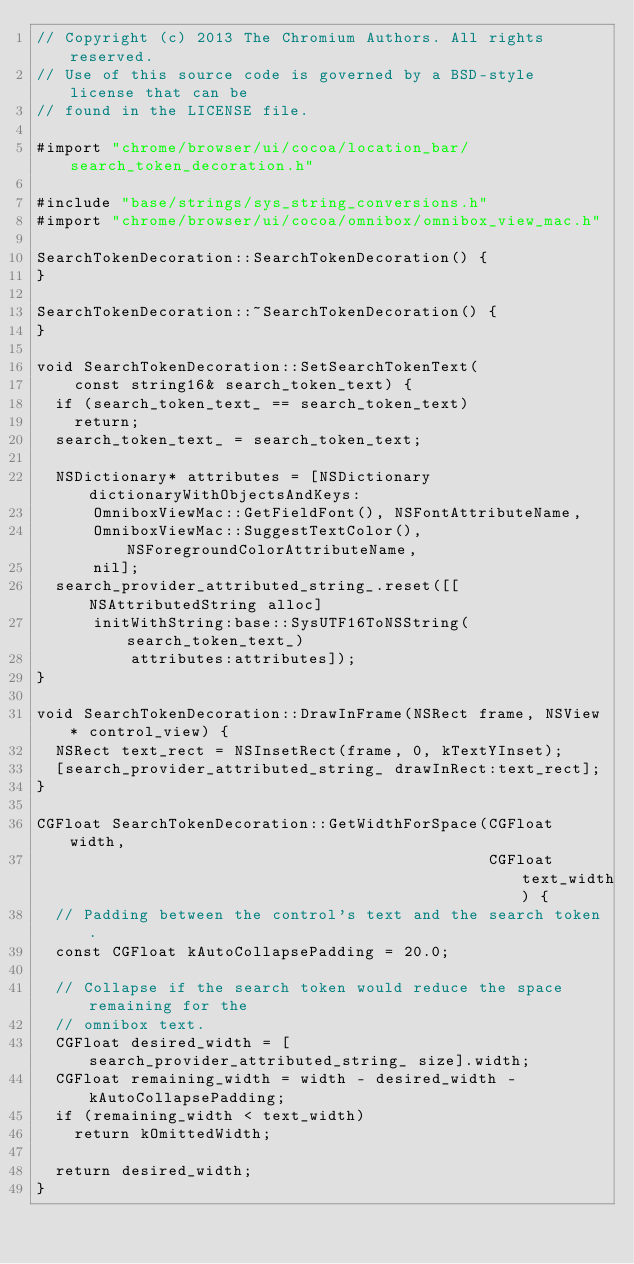<code> <loc_0><loc_0><loc_500><loc_500><_ObjectiveC_>// Copyright (c) 2013 The Chromium Authors. All rights reserved.
// Use of this source code is governed by a BSD-style license that can be
// found in the LICENSE file.

#import "chrome/browser/ui/cocoa/location_bar/search_token_decoration.h"

#include "base/strings/sys_string_conversions.h"
#import "chrome/browser/ui/cocoa/omnibox/omnibox_view_mac.h"

SearchTokenDecoration::SearchTokenDecoration() {
}

SearchTokenDecoration::~SearchTokenDecoration() {
}

void SearchTokenDecoration::SetSearchTokenText(
    const string16& search_token_text) {
  if (search_token_text_ == search_token_text)
    return;
  search_token_text_ = search_token_text;

  NSDictionary* attributes = [NSDictionary dictionaryWithObjectsAndKeys:
      OmniboxViewMac::GetFieldFont(), NSFontAttributeName,
      OmniboxViewMac::SuggestTextColor(), NSForegroundColorAttributeName,
      nil];
  search_provider_attributed_string_.reset([[NSAttributedString alloc]
      initWithString:base::SysUTF16ToNSString(search_token_text_)
          attributes:attributes]);
}

void SearchTokenDecoration::DrawInFrame(NSRect frame, NSView* control_view) {
  NSRect text_rect = NSInsetRect(frame, 0, kTextYInset);
  [search_provider_attributed_string_ drawInRect:text_rect];
}

CGFloat SearchTokenDecoration::GetWidthForSpace(CGFloat width,
                                                CGFloat text_width) {
  // Padding between the control's text and the search token.
  const CGFloat kAutoCollapsePadding = 20.0;

  // Collapse if the search token would reduce the space remaining for the
  // omnibox text.
  CGFloat desired_width = [search_provider_attributed_string_ size].width;
  CGFloat remaining_width = width - desired_width - kAutoCollapsePadding;
  if (remaining_width < text_width)
    return kOmittedWidth;

  return desired_width;
}
</code> 